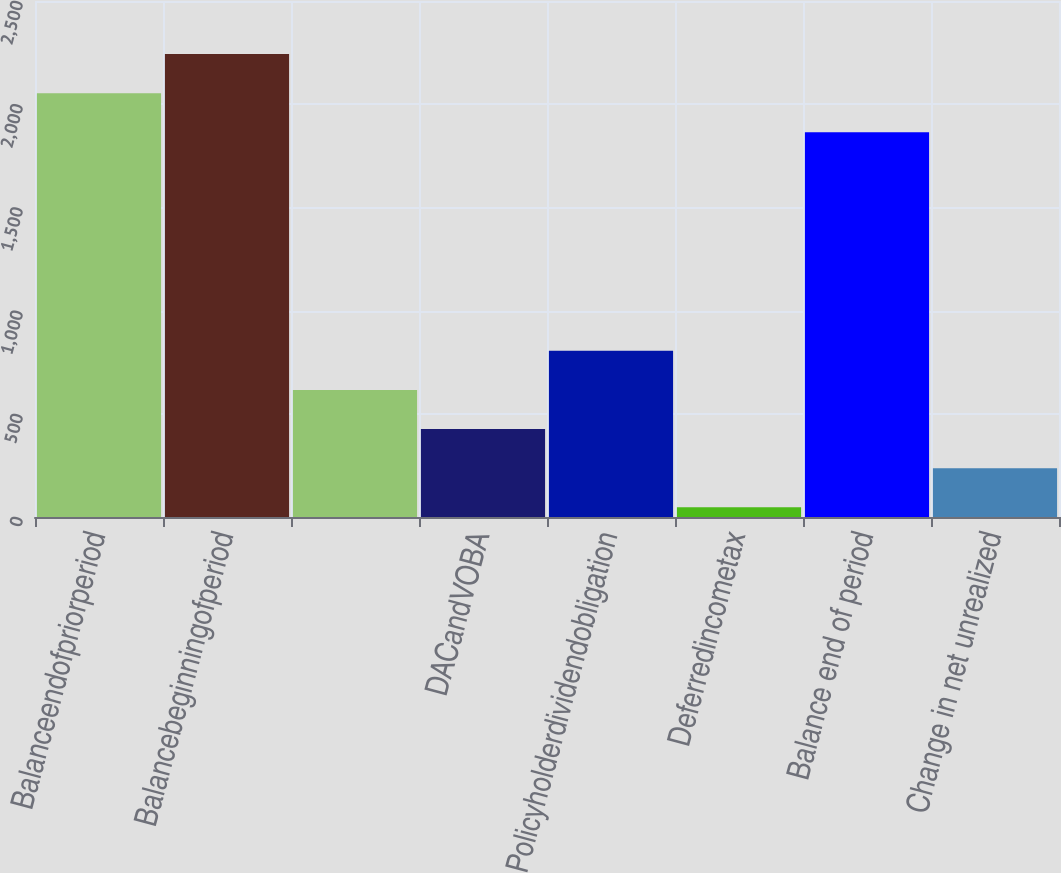<chart> <loc_0><loc_0><loc_500><loc_500><bar_chart><fcel>Balanceendofpriorperiod<fcel>Balancebeginningofperiod<fcel>Unnamed: 2<fcel>DACandVOBA<fcel>Policyholderdividendobligation<fcel>Deferredincometax<fcel>Balance end of period<fcel>Change in net unrealized<nl><fcel>2053.5<fcel>2243<fcel>615.5<fcel>426<fcel>805<fcel>47<fcel>1864<fcel>236.5<nl></chart> 